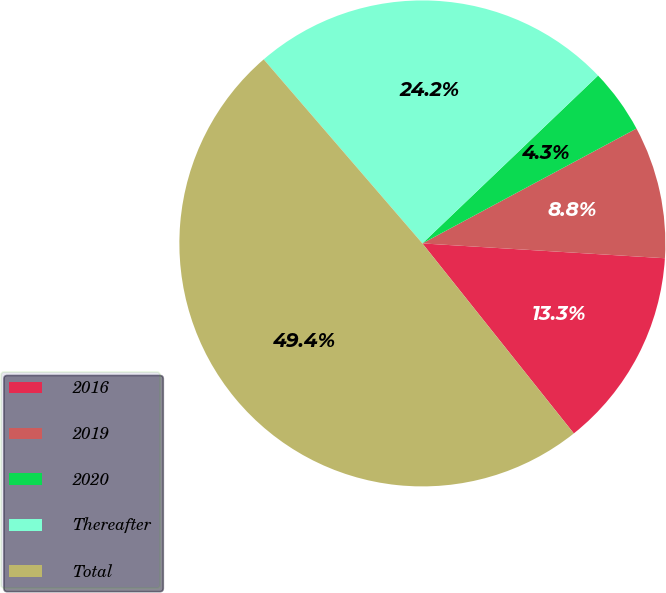Convert chart. <chart><loc_0><loc_0><loc_500><loc_500><pie_chart><fcel>2016<fcel>2019<fcel>2020<fcel>Thereafter<fcel>Total<nl><fcel>13.32%<fcel>8.81%<fcel>4.3%<fcel>24.19%<fcel>49.39%<nl></chart> 